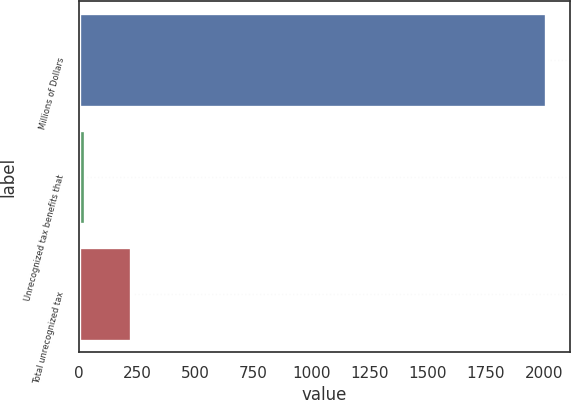Convert chart. <chart><loc_0><loc_0><loc_500><loc_500><bar_chart><fcel>Millions of Dollars<fcel>Unrecognized tax benefits that<fcel>Total unrecognized tax<nl><fcel>2009<fcel>25<fcel>223.4<nl></chart> 